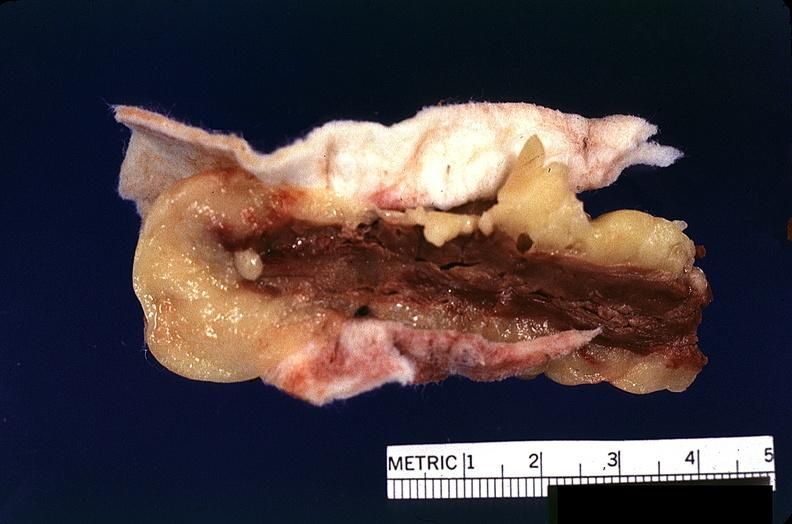does this image show heart, myocardial infarction, surgery to repair interventricular septum rupture?
Answer the question using a single word or phrase. Yes 